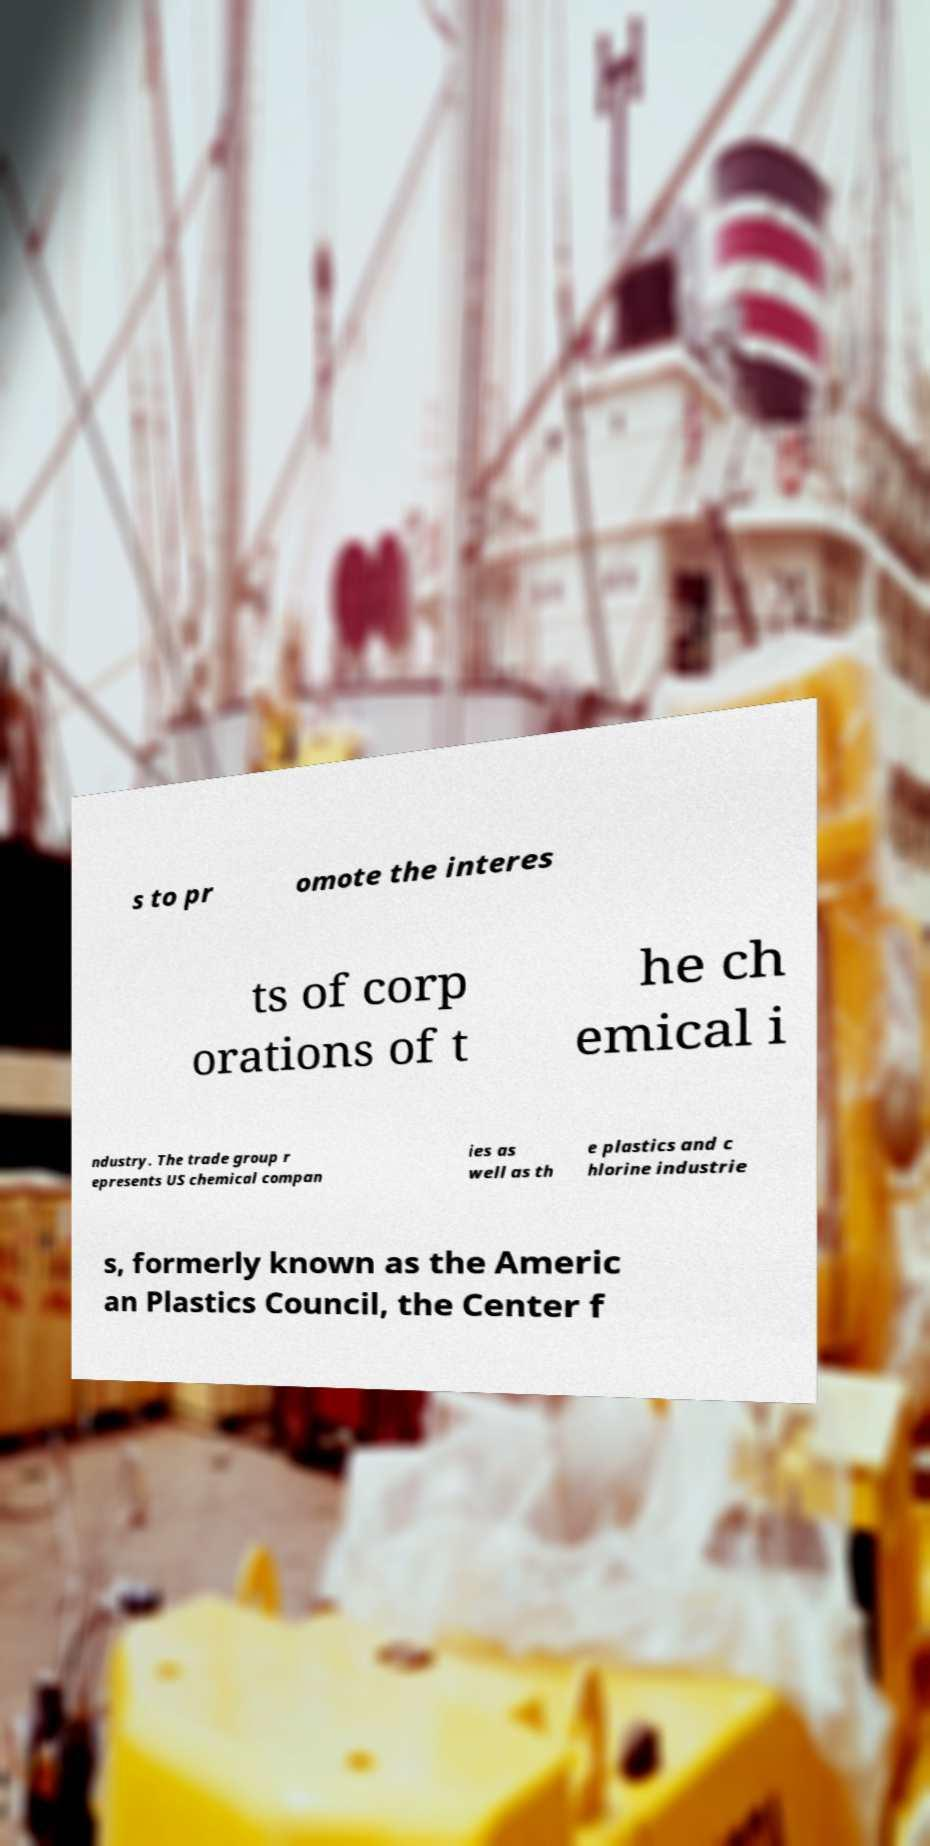There's text embedded in this image that I need extracted. Can you transcribe it verbatim? s to pr omote the interes ts of corp orations of t he ch emical i ndustry. The trade group r epresents US chemical compan ies as well as th e plastics and c hlorine industrie s, formerly known as the Americ an Plastics Council, the Center f 